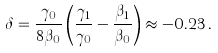Convert formula to latex. <formula><loc_0><loc_0><loc_500><loc_500>\delta = \frac { \gamma _ { 0 } } { 8 \beta _ { 0 } } \left ( \frac { \gamma _ { 1 } } { \gamma _ { 0 } } - \frac { \beta _ { 1 } } { \beta _ { 0 } } \right ) \approx - 0 . 2 3 \, .</formula> 